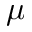Convert formula to latex. <formula><loc_0><loc_0><loc_500><loc_500>\mu</formula> 